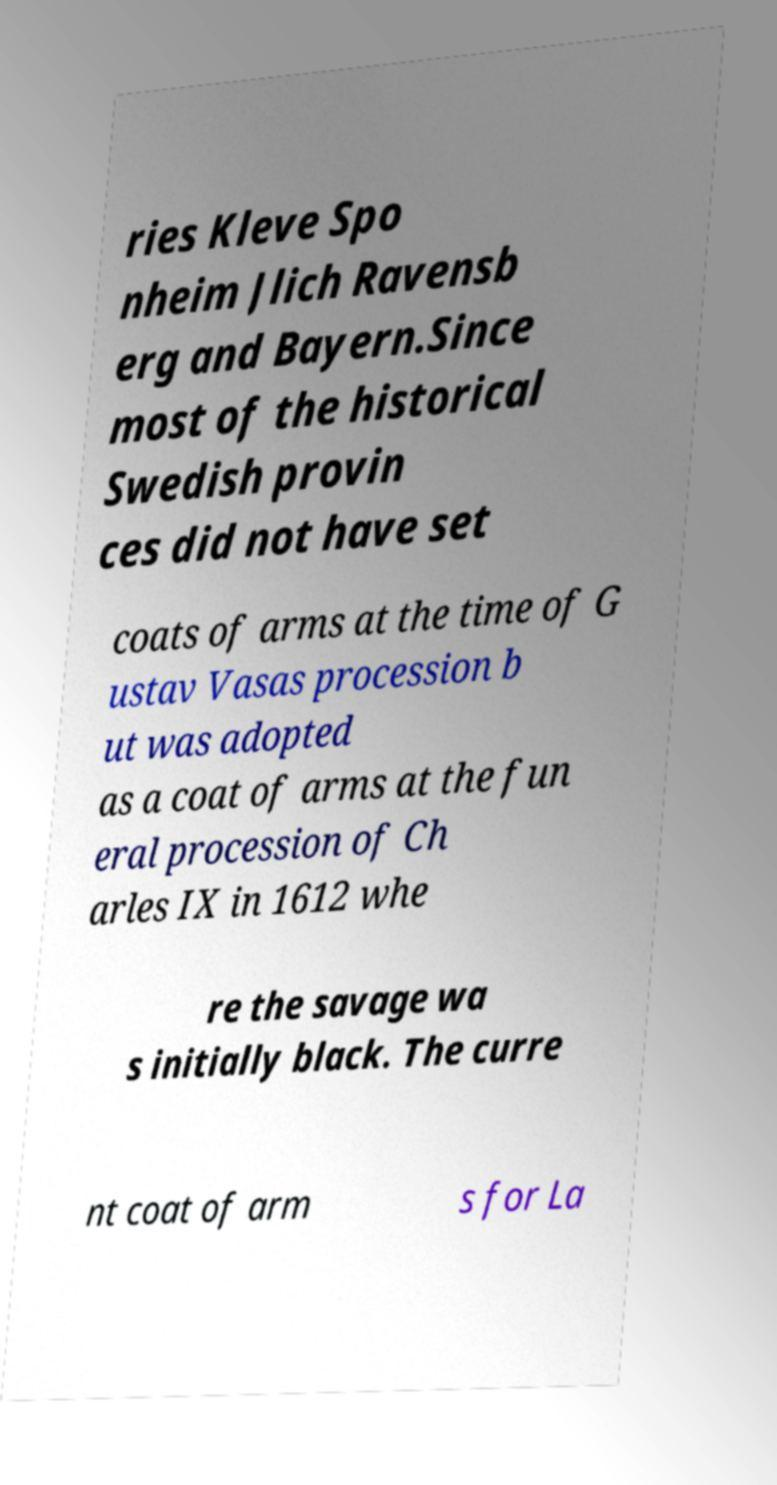Could you extract and type out the text from this image? ries Kleve Spo nheim Jlich Ravensb erg and Bayern.Since most of the historical Swedish provin ces did not have set coats of arms at the time of G ustav Vasas procession b ut was adopted as a coat of arms at the fun eral procession of Ch arles IX in 1612 whe re the savage wa s initially black. The curre nt coat of arm s for La 